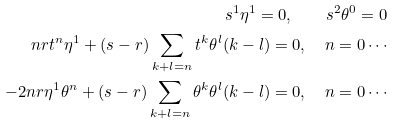<formula> <loc_0><loc_0><loc_500><loc_500>s ^ { 1 } \eta ^ { 1 } = 0 , \quad s ^ { 2 } \theta ^ { 0 } = 0 \\ n r t ^ { n } \eta ^ { 1 } + ( s - r ) \sum _ { k + l = n } t ^ { k } \theta ^ { l } ( k - l ) = 0 , \quad n = 0 \cdots \\ - 2 n r \eta ^ { 1 } \theta ^ { n } + ( s - r ) \sum _ { k + l = n } \theta ^ { k } \theta ^ { l } ( k - l ) = 0 , \quad n = 0 \cdots</formula> 